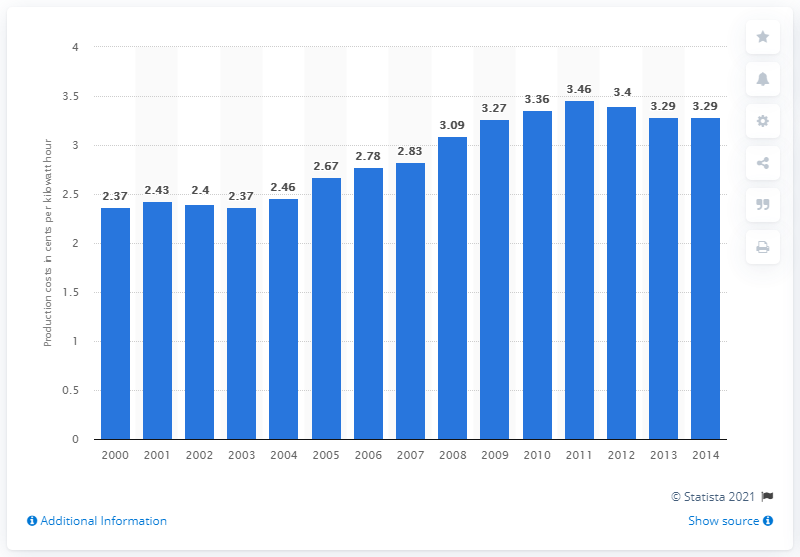Point out several critical features in this image. The cost of electricity generated from coal in dollar cents per kilowatt hour in 2013 was 3.29. 